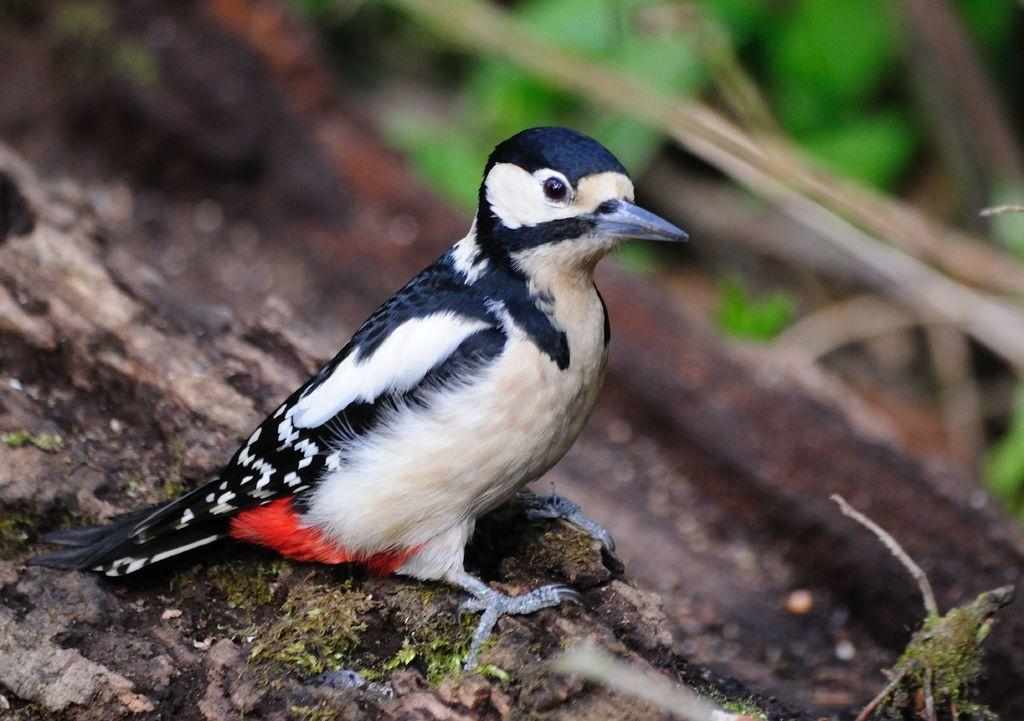Where was the image taken? The image was taken outdoors. What is visible at the bottom of the image? There is a bark at the bottom of the image. What can be seen on the bark in the middle of the image? There is a bird on the bark in the middle of the image. What type of lace can be seen hanging from the bird's beak in the image? There is no lace present in the image, and the bird's beak is not shown to be holding anything. 